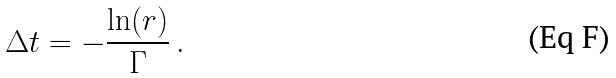Convert formula to latex. <formula><loc_0><loc_0><loc_500><loc_500>\Delta t = - \frac { \ln ( r ) } { \Gamma } \, .</formula> 